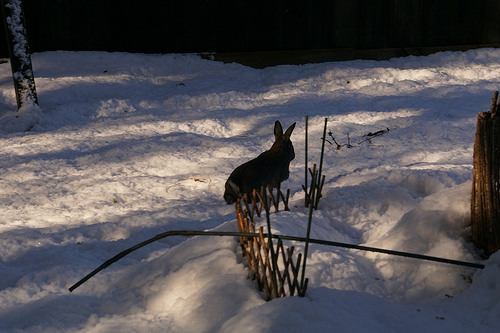<image>
Is the rabbit in front of the tree? Yes. The rabbit is positioned in front of the tree, appearing closer to the camera viewpoint. Where is the bunny in relation to the snow? Is it above the snow? No. The bunny is not positioned above the snow. The vertical arrangement shows a different relationship. 